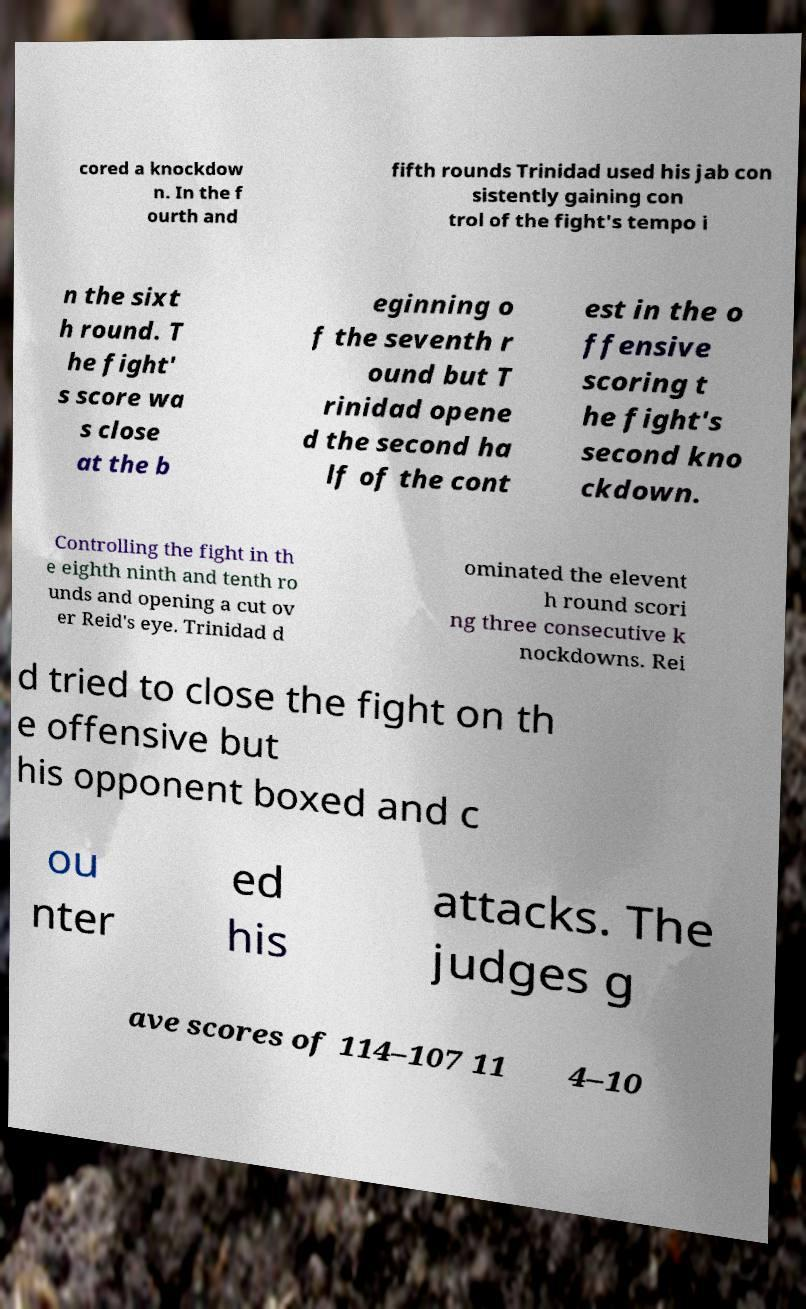What messages or text are displayed in this image? I need them in a readable, typed format. cored a knockdow n. In the f ourth and fifth rounds Trinidad used his jab con sistently gaining con trol of the fight's tempo i n the sixt h round. T he fight' s score wa s close at the b eginning o f the seventh r ound but T rinidad opene d the second ha lf of the cont est in the o ffensive scoring t he fight's second kno ckdown. Controlling the fight in th e eighth ninth and tenth ro unds and opening a cut ov er Reid's eye. Trinidad d ominated the elevent h round scori ng three consecutive k nockdowns. Rei d tried to close the fight on th e offensive but his opponent boxed and c ou nter ed his attacks. The judges g ave scores of 114–107 11 4–10 